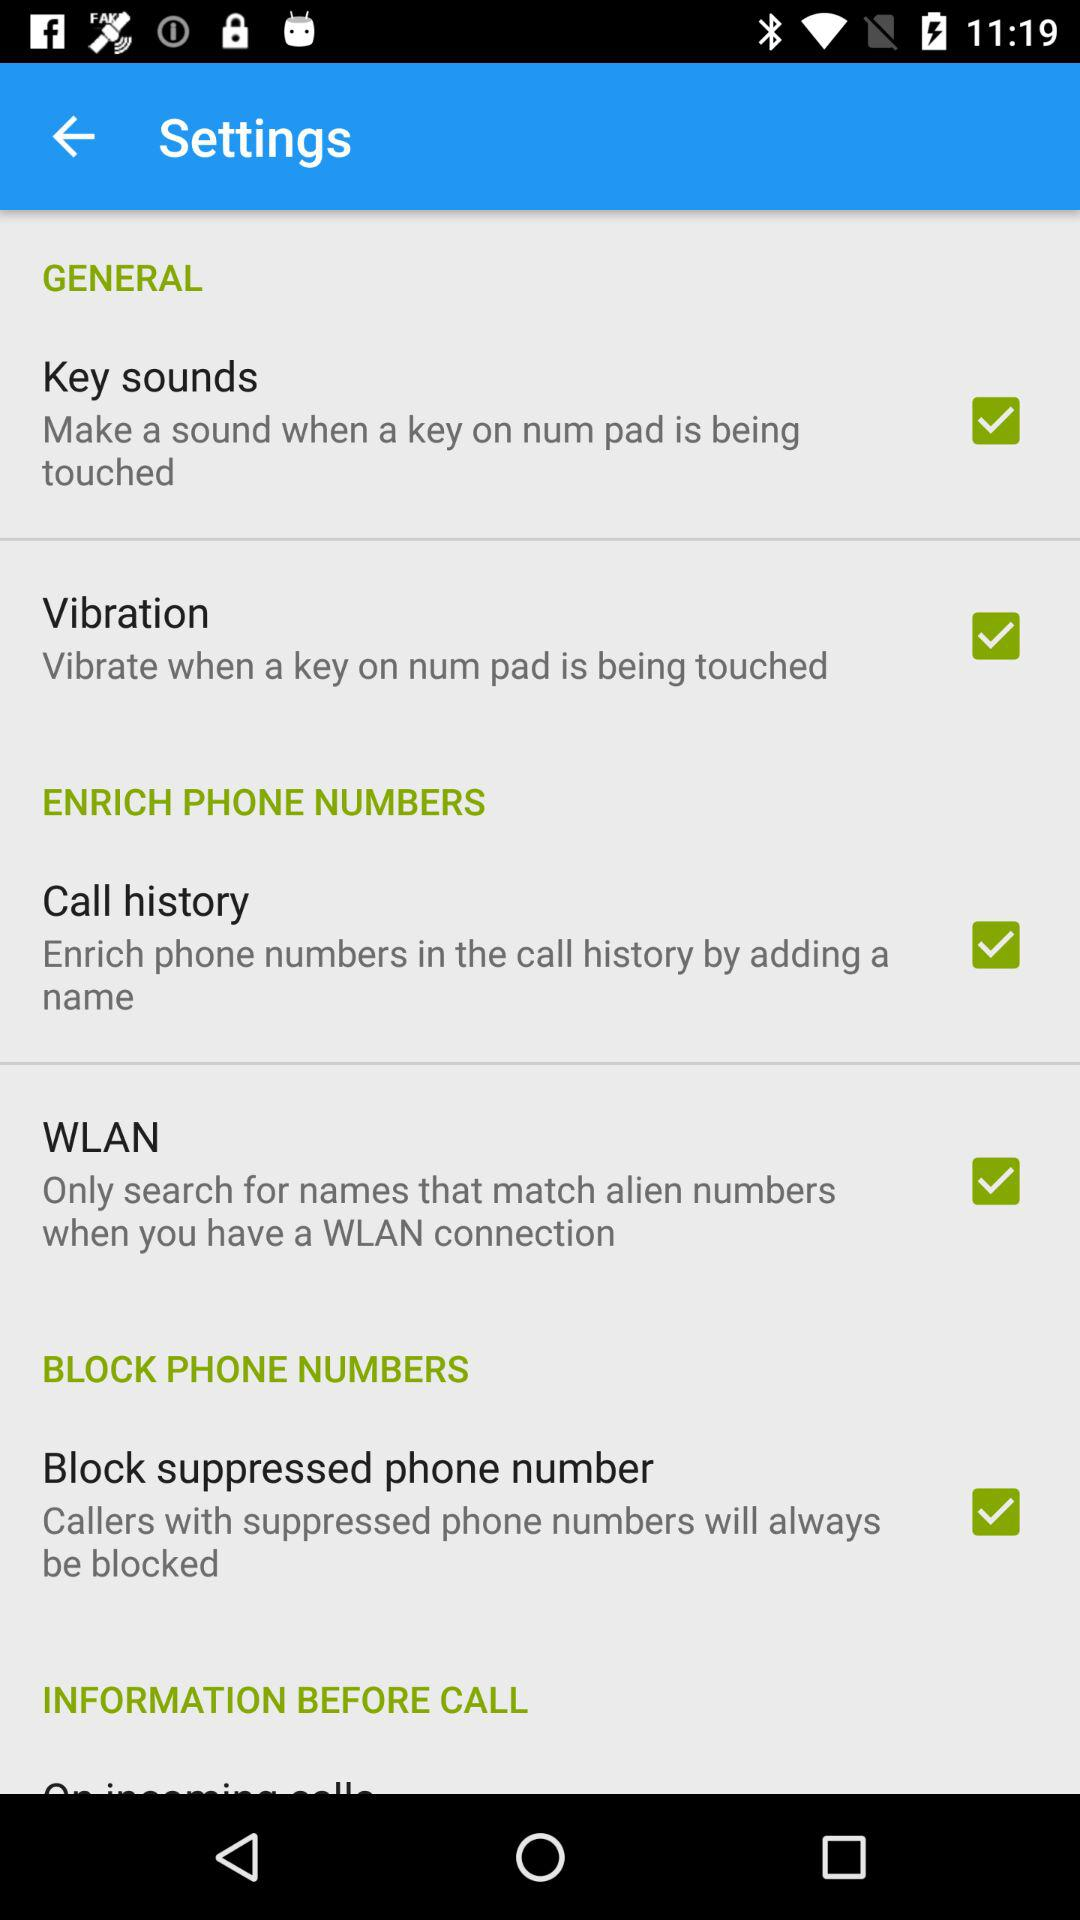What is the status of "Key sounds"? The status is "on". 